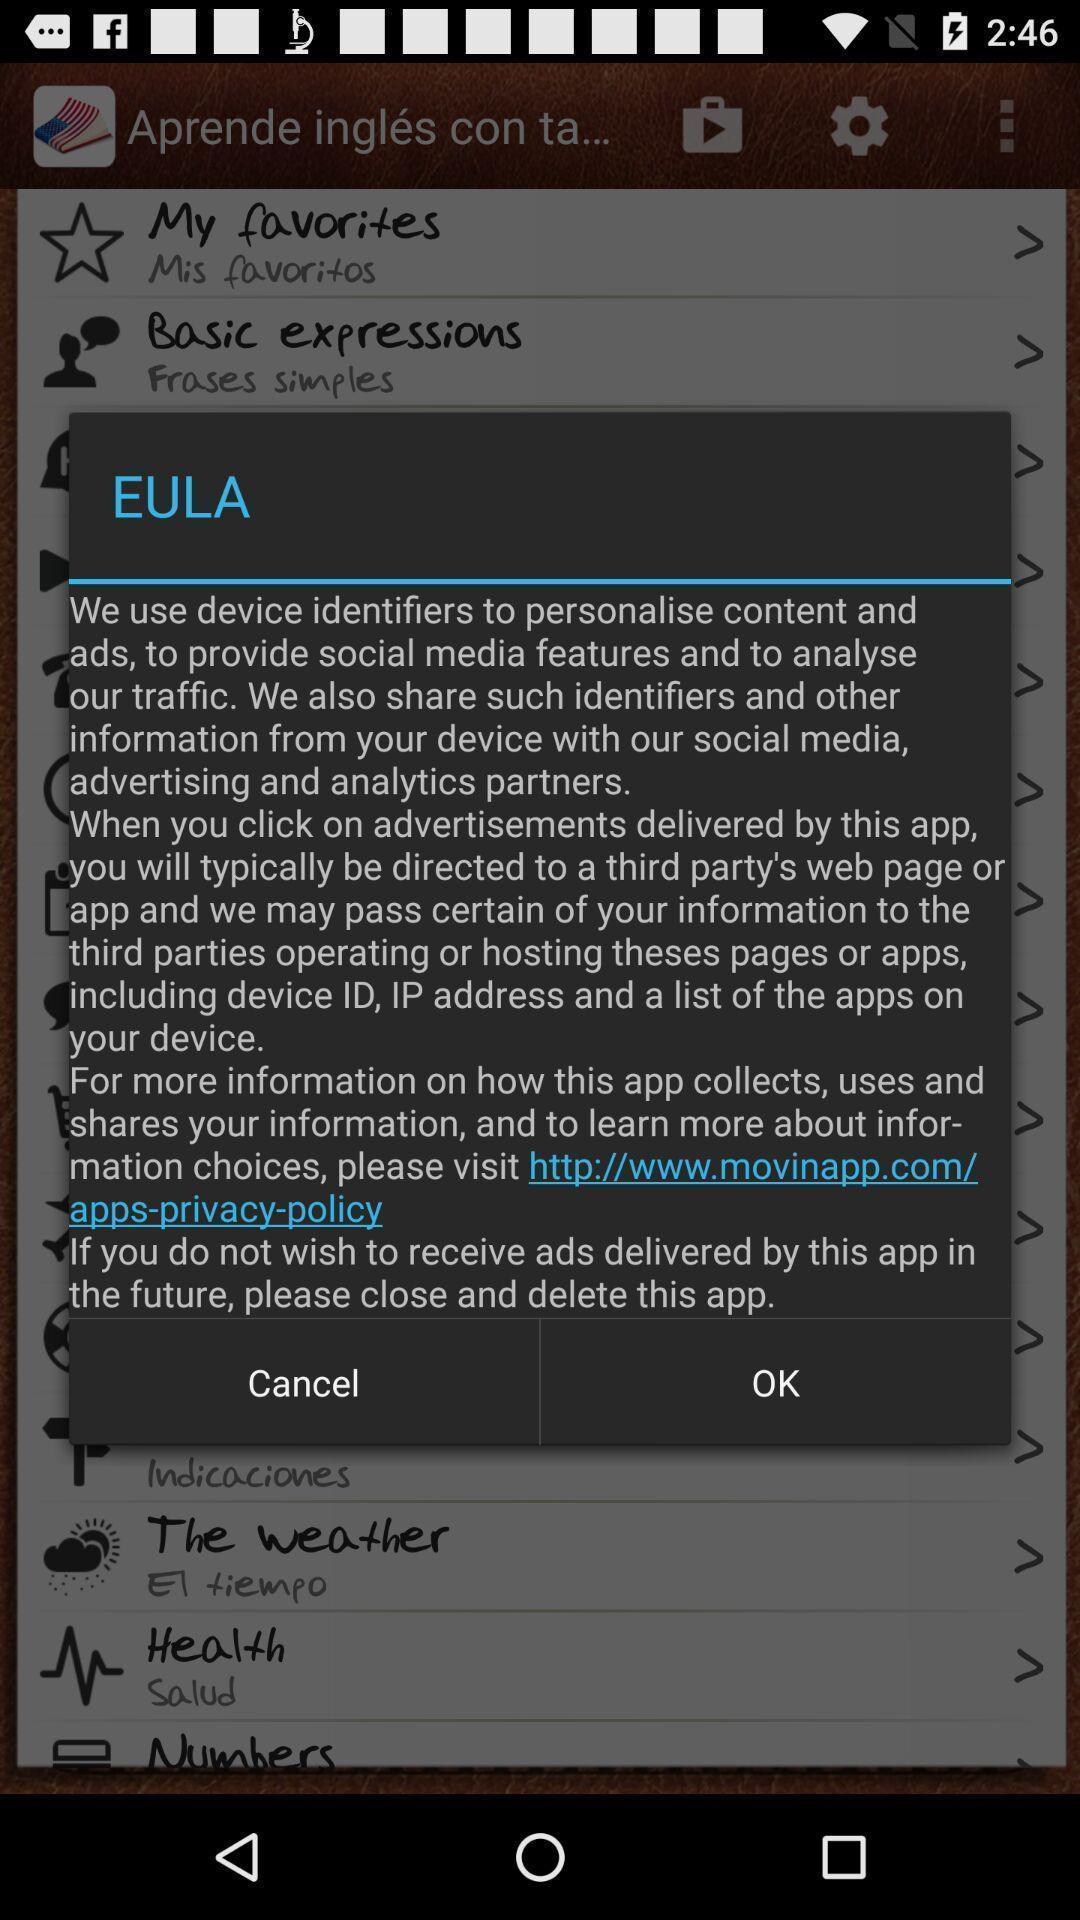Describe the content in this image. Pop-up displaying the license agreement. 